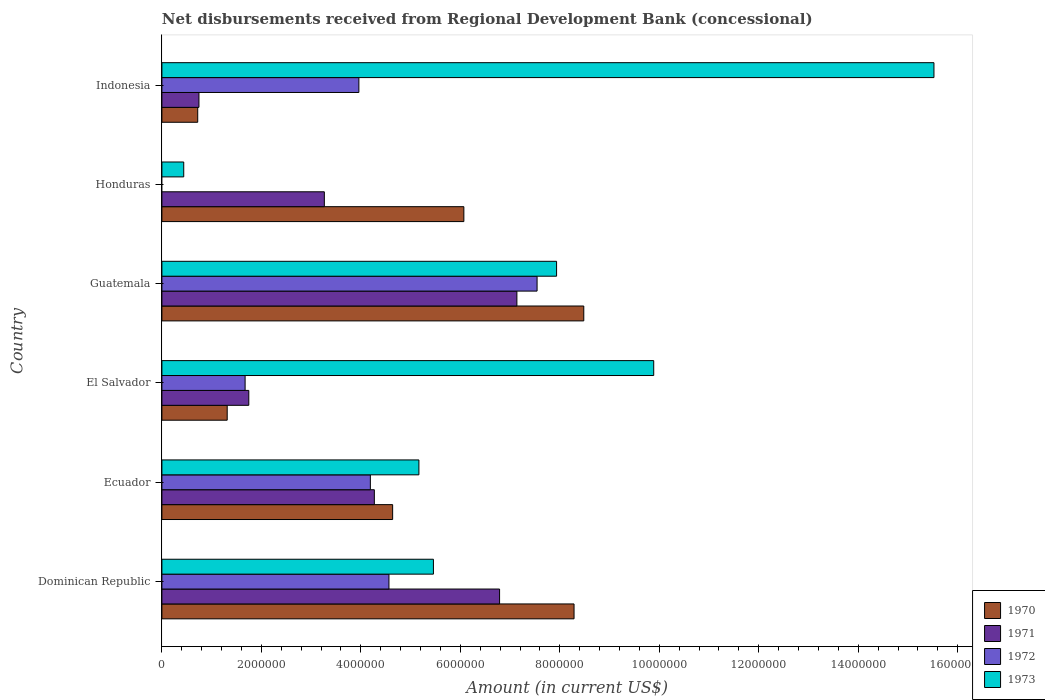How many different coloured bars are there?
Your answer should be very brief. 4. How many groups of bars are there?
Your answer should be compact. 6. Are the number of bars on each tick of the Y-axis equal?
Provide a short and direct response. No. What is the amount of disbursements received from Regional Development Bank in 1973 in Guatemala?
Your response must be concise. 7.94e+06. Across all countries, what is the maximum amount of disbursements received from Regional Development Bank in 1973?
Give a very brief answer. 1.55e+07. In which country was the amount of disbursements received from Regional Development Bank in 1970 maximum?
Ensure brevity in your answer.  Guatemala. What is the total amount of disbursements received from Regional Development Bank in 1971 in the graph?
Your answer should be compact. 2.40e+07. What is the difference between the amount of disbursements received from Regional Development Bank in 1973 in El Salvador and that in Guatemala?
Ensure brevity in your answer.  1.95e+06. What is the difference between the amount of disbursements received from Regional Development Bank in 1970 in Dominican Republic and the amount of disbursements received from Regional Development Bank in 1973 in Honduras?
Offer a terse response. 7.85e+06. What is the average amount of disbursements received from Regional Development Bank in 1970 per country?
Your answer should be compact. 4.92e+06. What is the difference between the amount of disbursements received from Regional Development Bank in 1970 and amount of disbursements received from Regional Development Bank in 1973 in Dominican Republic?
Offer a terse response. 2.83e+06. What is the ratio of the amount of disbursements received from Regional Development Bank in 1970 in Ecuador to that in El Salvador?
Provide a short and direct response. 3.53. Is the amount of disbursements received from Regional Development Bank in 1973 in Ecuador less than that in Guatemala?
Provide a short and direct response. Yes. What is the difference between the highest and the second highest amount of disbursements received from Regional Development Bank in 1973?
Make the answer very short. 5.63e+06. What is the difference between the highest and the lowest amount of disbursements received from Regional Development Bank in 1971?
Provide a succinct answer. 6.39e+06. Is the sum of the amount of disbursements received from Regional Development Bank in 1972 in Ecuador and Indonesia greater than the maximum amount of disbursements received from Regional Development Bank in 1970 across all countries?
Offer a terse response. No. Is it the case that in every country, the sum of the amount of disbursements received from Regional Development Bank in 1971 and amount of disbursements received from Regional Development Bank in 1970 is greater than the amount of disbursements received from Regional Development Bank in 1973?
Your answer should be compact. No. How many bars are there?
Offer a terse response. 23. Are all the bars in the graph horizontal?
Provide a succinct answer. Yes. How many countries are there in the graph?
Keep it short and to the point. 6. Are the values on the major ticks of X-axis written in scientific E-notation?
Make the answer very short. No. Does the graph contain any zero values?
Your answer should be compact. Yes. Where does the legend appear in the graph?
Your answer should be compact. Bottom right. How many legend labels are there?
Give a very brief answer. 4. How are the legend labels stacked?
Make the answer very short. Vertical. What is the title of the graph?
Keep it short and to the point. Net disbursements received from Regional Development Bank (concessional). What is the Amount (in current US$) in 1970 in Dominican Republic?
Keep it short and to the point. 8.29e+06. What is the Amount (in current US$) in 1971 in Dominican Republic?
Ensure brevity in your answer.  6.79e+06. What is the Amount (in current US$) of 1972 in Dominican Republic?
Provide a short and direct response. 4.56e+06. What is the Amount (in current US$) of 1973 in Dominican Republic?
Your answer should be compact. 5.46e+06. What is the Amount (in current US$) of 1970 in Ecuador?
Keep it short and to the point. 4.64e+06. What is the Amount (in current US$) of 1971 in Ecuador?
Keep it short and to the point. 4.27e+06. What is the Amount (in current US$) of 1972 in Ecuador?
Provide a succinct answer. 4.19e+06. What is the Amount (in current US$) of 1973 in Ecuador?
Keep it short and to the point. 5.17e+06. What is the Amount (in current US$) of 1970 in El Salvador?
Ensure brevity in your answer.  1.31e+06. What is the Amount (in current US$) of 1971 in El Salvador?
Offer a terse response. 1.75e+06. What is the Amount (in current US$) in 1972 in El Salvador?
Give a very brief answer. 1.67e+06. What is the Amount (in current US$) in 1973 in El Salvador?
Your answer should be very brief. 9.89e+06. What is the Amount (in current US$) of 1970 in Guatemala?
Keep it short and to the point. 8.48e+06. What is the Amount (in current US$) of 1971 in Guatemala?
Your answer should be compact. 7.14e+06. What is the Amount (in current US$) of 1972 in Guatemala?
Provide a succinct answer. 7.54e+06. What is the Amount (in current US$) of 1973 in Guatemala?
Your response must be concise. 7.94e+06. What is the Amount (in current US$) in 1970 in Honduras?
Make the answer very short. 6.07e+06. What is the Amount (in current US$) in 1971 in Honduras?
Offer a very short reply. 3.27e+06. What is the Amount (in current US$) of 1973 in Honduras?
Make the answer very short. 4.39e+05. What is the Amount (in current US$) in 1970 in Indonesia?
Offer a terse response. 7.20e+05. What is the Amount (in current US$) in 1971 in Indonesia?
Provide a short and direct response. 7.45e+05. What is the Amount (in current US$) in 1972 in Indonesia?
Make the answer very short. 3.96e+06. What is the Amount (in current US$) of 1973 in Indonesia?
Offer a terse response. 1.55e+07. Across all countries, what is the maximum Amount (in current US$) of 1970?
Offer a very short reply. 8.48e+06. Across all countries, what is the maximum Amount (in current US$) in 1971?
Provide a succinct answer. 7.14e+06. Across all countries, what is the maximum Amount (in current US$) of 1972?
Make the answer very short. 7.54e+06. Across all countries, what is the maximum Amount (in current US$) of 1973?
Give a very brief answer. 1.55e+07. Across all countries, what is the minimum Amount (in current US$) of 1970?
Keep it short and to the point. 7.20e+05. Across all countries, what is the minimum Amount (in current US$) of 1971?
Make the answer very short. 7.45e+05. Across all countries, what is the minimum Amount (in current US$) in 1972?
Provide a succinct answer. 0. Across all countries, what is the minimum Amount (in current US$) in 1973?
Provide a short and direct response. 4.39e+05. What is the total Amount (in current US$) of 1970 in the graph?
Provide a succinct answer. 2.95e+07. What is the total Amount (in current US$) in 1971 in the graph?
Ensure brevity in your answer.  2.40e+07. What is the total Amount (in current US$) in 1972 in the graph?
Your response must be concise. 2.19e+07. What is the total Amount (in current US$) in 1973 in the graph?
Your answer should be very brief. 4.44e+07. What is the difference between the Amount (in current US$) in 1970 in Dominican Republic and that in Ecuador?
Provide a short and direct response. 3.65e+06. What is the difference between the Amount (in current US$) in 1971 in Dominican Republic and that in Ecuador?
Make the answer very short. 2.52e+06. What is the difference between the Amount (in current US$) of 1972 in Dominican Republic and that in Ecuador?
Ensure brevity in your answer.  3.74e+05. What is the difference between the Amount (in current US$) in 1973 in Dominican Republic and that in Ecuador?
Your answer should be compact. 2.92e+05. What is the difference between the Amount (in current US$) in 1970 in Dominican Republic and that in El Salvador?
Keep it short and to the point. 6.97e+06. What is the difference between the Amount (in current US$) in 1971 in Dominican Republic and that in El Salvador?
Provide a succinct answer. 5.04e+06. What is the difference between the Amount (in current US$) in 1972 in Dominican Republic and that in El Salvador?
Your response must be concise. 2.89e+06. What is the difference between the Amount (in current US$) of 1973 in Dominican Republic and that in El Salvador?
Your answer should be very brief. -4.43e+06. What is the difference between the Amount (in current US$) in 1970 in Dominican Republic and that in Guatemala?
Offer a very short reply. -1.96e+05. What is the difference between the Amount (in current US$) in 1971 in Dominican Republic and that in Guatemala?
Make the answer very short. -3.48e+05. What is the difference between the Amount (in current US$) of 1972 in Dominican Republic and that in Guatemala?
Provide a succinct answer. -2.98e+06. What is the difference between the Amount (in current US$) in 1973 in Dominican Republic and that in Guatemala?
Offer a terse response. -2.48e+06. What is the difference between the Amount (in current US$) in 1970 in Dominican Republic and that in Honduras?
Ensure brevity in your answer.  2.22e+06. What is the difference between the Amount (in current US$) in 1971 in Dominican Republic and that in Honduras?
Make the answer very short. 3.52e+06. What is the difference between the Amount (in current US$) in 1973 in Dominican Republic and that in Honduras?
Provide a short and direct response. 5.02e+06. What is the difference between the Amount (in current US$) in 1970 in Dominican Republic and that in Indonesia?
Provide a succinct answer. 7.57e+06. What is the difference between the Amount (in current US$) in 1971 in Dominican Republic and that in Indonesia?
Your answer should be very brief. 6.04e+06. What is the difference between the Amount (in current US$) in 1972 in Dominican Republic and that in Indonesia?
Your response must be concise. 6.05e+05. What is the difference between the Amount (in current US$) of 1973 in Dominican Republic and that in Indonesia?
Give a very brief answer. -1.01e+07. What is the difference between the Amount (in current US$) in 1970 in Ecuador and that in El Salvador?
Your answer should be compact. 3.33e+06. What is the difference between the Amount (in current US$) of 1971 in Ecuador and that in El Salvador?
Make the answer very short. 2.52e+06. What is the difference between the Amount (in current US$) of 1972 in Ecuador and that in El Salvador?
Your answer should be compact. 2.52e+06. What is the difference between the Amount (in current US$) in 1973 in Ecuador and that in El Salvador?
Ensure brevity in your answer.  -4.72e+06. What is the difference between the Amount (in current US$) of 1970 in Ecuador and that in Guatemala?
Your answer should be very brief. -3.84e+06. What is the difference between the Amount (in current US$) in 1971 in Ecuador and that in Guatemala?
Provide a succinct answer. -2.87e+06. What is the difference between the Amount (in current US$) in 1972 in Ecuador and that in Guatemala?
Provide a succinct answer. -3.35e+06. What is the difference between the Amount (in current US$) of 1973 in Ecuador and that in Guatemala?
Your answer should be very brief. -2.77e+06. What is the difference between the Amount (in current US$) of 1970 in Ecuador and that in Honduras?
Provide a succinct answer. -1.43e+06. What is the difference between the Amount (in current US$) of 1971 in Ecuador and that in Honduras?
Provide a short and direct response. 1.00e+06. What is the difference between the Amount (in current US$) in 1973 in Ecuador and that in Honduras?
Offer a terse response. 4.73e+06. What is the difference between the Amount (in current US$) of 1970 in Ecuador and that in Indonesia?
Offer a very short reply. 3.92e+06. What is the difference between the Amount (in current US$) of 1971 in Ecuador and that in Indonesia?
Offer a terse response. 3.53e+06. What is the difference between the Amount (in current US$) of 1972 in Ecuador and that in Indonesia?
Offer a very short reply. 2.31e+05. What is the difference between the Amount (in current US$) in 1973 in Ecuador and that in Indonesia?
Give a very brief answer. -1.04e+07. What is the difference between the Amount (in current US$) of 1970 in El Salvador and that in Guatemala?
Provide a short and direct response. -7.17e+06. What is the difference between the Amount (in current US$) in 1971 in El Salvador and that in Guatemala?
Give a very brief answer. -5.39e+06. What is the difference between the Amount (in current US$) in 1972 in El Salvador and that in Guatemala?
Your response must be concise. -5.87e+06. What is the difference between the Amount (in current US$) in 1973 in El Salvador and that in Guatemala?
Give a very brief answer. 1.95e+06. What is the difference between the Amount (in current US$) of 1970 in El Salvador and that in Honduras?
Your answer should be compact. -4.76e+06. What is the difference between the Amount (in current US$) of 1971 in El Salvador and that in Honduras?
Provide a succinct answer. -1.52e+06. What is the difference between the Amount (in current US$) of 1973 in El Salvador and that in Honduras?
Keep it short and to the point. 9.45e+06. What is the difference between the Amount (in current US$) of 1970 in El Salvador and that in Indonesia?
Provide a succinct answer. 5.93e+05. What is the difference between the Amount (in current US$) of 1971 in El Salvador and that in Indonesia?
Offer a terse response. 1.00e+06. What is the difference between the Amount (in current US$) in 1972 in El Salvador and that in Indonesia?
Your response must be concise. -2.29e+06. What is the difference between the Amount (in current US$) in 1973 in El Salvador and that in Indonesia?
Offer a very short reply. -5.63e+06. What is the difference between the Amount (in current US$) in 1970 in Guatemala and that in Honduras?
Offer a very short reply. 2.41e+06. What is the difference between the Amount (in current US$) of 1971 in Guatemala and that in Honduras?
Make the answer very short. 3.87e+06. What is the difference between the Amount (in current US$) of 1973 in Guatemala and that in Honduras?
Provide a succinct answer. 7.50e+06. What is the difference between the Amount (in current US$) of 1970 in Guatemala and that in Indonesia?
Provide a short and direct response. 7.76e+06. What is the difference between the Amount (in current US$) of 1971 in Guatemala and that in Indonesia?
Make the answer very short. 6.39e+06. What is the difference between the Amount (in current US$) in 1972 in Guatemala and that in Indonesia?
Your answer should be very brief. 3.58e+06. What is the difference between the Amount (in current US$) in 1973 in Guatemala and that in Indonesia?
Your answer should be compact. -7.59e+06. What is the difference between the Amount (in current US$) of 1970 in Honduras and that in Indonesia?
Provide a succinct answer. 5.35e+06. What is the difference between the Amount (in current US$) of 1971 in Honduras and that in Indonesia?
Ensure brevity in your answer.  2.52e+06. What is the difference between the Amount (in current US$) of 1973 in Honduras and that in Indonesia?
Your answer should be compact. -1.51e+07. What is the difference between the Amount (in current US$) in 1970 in Dominican Republic and the Amount (in current US$) in 1971 in Ecuador?
Your response must be concise. 4.02e+06. What is the difference between the Amount (in current US$) in 1970 in Dominican Republic and the Amount (in current US$) in 1972 in Ecuador?
Make the answer very short. 4.10e+06. What is the difference between the Amount (in current US$) of 1970 in Dominican Republic and the Amount (in current US$) of 1973 in Ecuador?
Make the answer very short. 3.12e+06. What is the difference between the Amount (in current US$) of 1971 in Dominican Republic and the Amount (in current US$) of 1972 in Ecuador?
Give a very brief answer. 2.60e+06. What is the difference between the Amount (in current US$) in 1971 in Dominican Republic and the Amount (in current US$) in 1973 in Ecuador?
Your answer should be compact. 1.62e+06. What is the difference between the Amount (in current US$) in 1972 in Dominican Republic and the Amount (in current US$) in 1973 in Ecuador?
Provide a succinct answer. -6.02e+05. What is the difference between the Amount (in current US$) in 1970 in Dominican Republic and the Amount (in current US$) in 1971 in El Salvador?
Keep it short and to the point. 6.54e+06. What is the difference between the Amount (in current US$) of 1970 in Dominican Republic and the Amount (in current US$) of 1972 in El Salvador?
Provide a succinct answer. 6.61e+06. What is the difference between the Amount (in current US$) in 1970 in Dominican Republic and the Amount (in current US$) in 1973 in El Salvador?
Offer a very short reply. -1.60e+06. What is the difference between the Amount (in current US$) in 1971 in Dominican Republic and the Amount (in current US$) in 1972 in El Salvador?
Offer a very short reply. 5.12e+06. What is the difference between the Amount (in current US$) of 1971 in Dominican Republic and the Amount (in current US$) of 1973 in El Salvador?
Ensure brevity in your answer.  -3.10e+06. What is the difference between the Amount (in current US$) of 1972 in Dominican Republic and the Amount (in current US$) of 1973 in El Salvador?
Provide a succinct answer. -5.32e+06. What is the difference between the Amount (in current US$) of 1970 in Dominican Republic and the Amount (in current US$) of 1971 in Guatemala?
Your answer should be compact. 1.15e+06. What is the difference between the Amount (in current US$) of 1970 in Dominican Republic and the Amount (in current US$) of 1972 in Guatemala?
Your answer should be very brief. 7.43e+05. What is the difference between the Amount (in current US$) of 1970 in Dominican Republic and the Amount (in current US$) of 1973 in Guatemala?
Your response must be concise. 3.51e+05. What is the difference between the Amount (in current US$) in 1971 in Dominican Republic and the Amount (in current US$) in 1972 in Guatemala?
Provide a short and direct response. -7.54e+05. What is the difference between the Amount (in current US$) in 1971 in Dominican Republic and the Amount (in current US$) in 1973 in Guatemala?
Your answer should be compact. -1.15e+06. What is the difference between the Amount (in current US$) in 1972 in Dominican Republic and the Amount (in current US$) in 1973 in Guatemala?
Provide a short and direct response. -3.37e+06. What is the difference between the Amount (in current US$) in 1970 in Dominican Republic and the Amount (in current US$) in 1971 in Honduras?
Make the answer very short. 5.02e+06. What is the difference between the Amount (in current US$) of 1970 in Dominican Republic and the Amount (in current US$) of 1973 in Honduras?
Give a very brief answer. 7.85e+06. What is the difference between the Amount (in current US$) of 1971 in Dominican Republic and the Amount (in current US$) of 1973 in Honduras?
Provide a short and direct response. 6.35e+06. What is the difference between the Amount (in current US$) in 1972 in Dominican Republic and the Amount (in current US$) in 1973 in Honduras?
Your answer should be compact. 4.13e+06. What is the difference between the Amount (in current US$) of 1970 in Dominican Republic and the Amount (in current US$) of 1971 in Indonesia?
Keep it short and to the point. 7.54e+06. What is the difference between the Amount (in current US$) in 1970 in Dominican Republic and the Amount (in current US$) in 1972 in Indonesia?
Ensure brevity in your answer.  4.33e+06. What is the difference between the Amount (in current US$) in 1970 in Dominican Republic and the Amount (in current US$) in 1973 in Indonesia?
Give a very brief answer. -7.24e+06. What is the difference between the Amount (in current US$) of 1971 in Dominican Republic and the Amount (in current US$) of 1972 in Indonesia?
Your response must be concise. 2.83e+06. What is the difference between the Amount (in current US$) of 1971 in Dominican Republic and the Amount (in current US$) of 1973 in Indonesia?
Your response must be concise. -8.73e+06. What is the difference between the Amount (in current US$) in 1972 in Dominican Republic and the Amount (in current US$) in 1973 in Indonesia?
Provide a succinct answer. -1.10e+07. What is the difference between the Amount (in current US$) in 1970 in Ecuador and the Amount (in current US$) in 1971 in El Salvador?
Offer a very short reply. 2.89e+06. What is the difference between the Amount (in current US$) in 1970 in Ecuador and the Amount (in current US$) in 1972 in El Salvador?
Your response must be concise. 2.97e+06. What is the difference between the Amount (in current US$) in 1970 in Ecuador and the Amount (in current US$) in 1973 in El Salvador?
Keep it short and to the point. -5.25e+06. What is the difference between the Amount (in current US$) in 1971 in Ecuador and the Amount (in current US$) in 1972 in El Salvador?
Provide a succinct answer. 2.60e+06. What is the difference between the Amount (in current US$) in 1971 in Ecuador and the Amount (in current US$) in 1973 in El Salvador?
Make the answer very short. -5.62e+06. What is the difference between the Amount (in current US$) of 1972 in Ecuador and the Amount (in current US$) of 1973 in El Salvador?
Offer a very short reply. -5.70e+06. What is the difference between the Amount (in current US$) of 1970 in Ecuador and the Amount (in current US$) of 1971 in Guatemala?
Give a very brief answer. -2.50e+06. What is the difference between the Amount (in current US$) in 1970 in Ecuador and the Amount (in current US$) in 1972 in Guatemala?
Provide a succinct answer. -2.90e+06. What is the difference between the Amount (in current US$) of 1970 in Ecuador and the Amount (in current US$) of 1973 in Guatemala?
Offer a very short reply. -3.30e+06. What is the difference between the Amount (in current US$) in 1971 in Ecuador and the Amount (in current US$) in 1972 in Guatemala?
Provide a succinct answer. -3.27e+06. What is the difference between the Amount (in current US$) of 1971 in Ecuador and the Amount (in current US$) of 1973 in Guatemala?
Provide a succinct answer. -3.66e+06. What is the difference between the Amount (in current US$) in 1972 in Ecuador and the Amount (in current US$) in 1973 in Guatemala?
Offer a very short reply. -3.74e+06. What is the difference between the Amount (in current US$) in 1970 in Ecuador and the Amount (in current US$) in 1971 in Honduras?
Keep it short and to the point. 1.37e+06. What is the difference between the Amount (in current US$) of 1970 in Ecuador and the Amount (in current US$) of 1973 in Honduras?
Offer a terse response. 4.20e+06. What is the difference between the Amount (in current US$) of 1971 in Ecuador and the Amount (in current US$) of 1973 in Honduras?
Your answer should be compact. 3.83e+06. What is the difference between the Amount (in current US$) in 1972 in Ecuador and the Amount (in current US$) in 1973 in Honduras?
Offer a terse response. 3.75e+06. What is the difference between the Amount (in current US$) in 1970 in Ecuador and the Amount (in current US$) in 1971 in Indonesia?
Offer a very short reply. 3.89e+06. What is the difference between the Amount (in current US$) of 1970 in Ecuador and the Amount (in current US$) of 1972 in Indonesia?
Provide a succinct answer. 6.79e+05. What is the difference between the Amount (in current US$) of 1970 in Ecuador and the Amount (in current US$) of 1973 in Indonesia?
Your response must be concise. -1.09e+07. What is the difference between the Amount (in current US$) in 1971 in Ecuador and the Amount (in current US$) in 1972 in Indonesia?
Provide a short and direct response. 3.11e+05. What is the difference between the Amount (in current US$) in 1971 in Ecuador and the Amount (in current US$) in 1973 in Indonesia?
Make the answer very short. -1.13e+07. What is the difference between the Amount (in current US$) of 1972 in Ecuador and the Amount (in current US$) of 1973 in Indonesia?
Provide a short and direct response. -1.13e+07. What is the difference between the Amount (in current US$) in 1970 in El Salvador and the Amount (in current US$) in 1971 in Guatemala?
Offer a terse response. -5.82e+06. What is the difference between the Amount (in current US$) in 1970 in El Salvador and the Amount (in current US$) in 1972 in Guatemala?
Give a very brief answer. -6.23e+06. What is the difference between the Amount (in current US$) in 1970 in El Salvador and the Amount (in current US$) in 1973 in Guatemala?
Give a very brief answer. -6.62e+06. What is the difference between the Amount (in current US$) in 1971 in El Salvador and the Amount (in current US$) in 1972 in Guatemala?
Your answer should be compact. -5.80e+06. What is the difference between the Amount (in current US$) of 1971 in El Salvador and the Amount (in current US$) of 1973 in Guatemala?
Keep it short and to the point. -6.19e+06. What is the difference between the Amount (in current US$) in 1972 in El Salvador and the Amount (in current US$) in 1973 in Guatemala?
Give a very brief answer. -6.26e+06. What is the difference between the Amount (in current US$) of 1970 in El Salvador and the Amount (in current US$) of 1971 in Honduras?
Offer a very short reply. -1.95e+06. What is the difference between the Amount (in current US$) of 1970 in El Salvador and the Amount (in current US$) of 1973 in Honduras?
Give a very brief answer. 8.74e+05. What is the difference between the Amount (in current US$) of 1971 in El Salvador and the Amount (in current US$) of 1973 in Honduras?
Offer a terse response. 1.31e+06. What is the difference between the Amount (in current US$) of 1972 in El Salvador and the Amount (in current US$) of 1973 in Honduras?
Your answer should be compact. 1.23e+06. What is the difference between the Amount (in current US$) in 1970 in El Salvador and the Amount (in current US$) in 1971 in Indonesia?
Offer a very short reply. 5.68e+05. What is the difference between the Amount (in current US$) in 1970 in El Salvador and the Amount (in current US$) in 1972 in Indonesia?
Offer a very short reply. -2.65e+06. What is the difference between the Amount (in current US$) of 1970 in El Salvador and the Amount (in current US$) of 1973 in Indonesia?
Give a very brief answer. -1.42e+07. What is the difference between the Amount (in current US$) in 1971 in El Salvador and the Amount (in current US$) in 1972 in Indonesia?
Your answer should be very brief. -2.21e+06. What is the difference between the Amount (in current US$) in 1971 in El Salvador and the Amount (in current US$) in 1973 in Indonesia?
Provide a succinct answer. -1.38e+07. What is the difference between the Amount (in current US$) in 1972 in El Salvador and the Amount (in current US$) in 1973 in Indonesia?
Give a very brief answer. -1.38e+07. What is the difference between the Amount (in current US$) in 1970 in Guatemala and the Amount (in current US$) in 1971 in Honduras?
Keep it short and to the point. 5.22e+06. What is the difference between the Amount (in current US$) in 1970 in Guatemala and the Amount (in current US$) in 1973 in Honduras?
Make the answer very short. 8.04e+06. What is the difference between the Amount (in current US$) of 1971 in Guatemala and the Amount (in current US$) of 1973 in Honduras?
Your answer should be compact. 6.70e+06. What is the difference between the Amount (in current US$) of 1972 in Guatemala and the Amount (in current US$) of 1973 in Honduras?
Make the answer very short. 7.10e+06. What is the difference between the Amount (in current US$) in 1970 in Guatemala and the Amount (in current US$) in 1971 in Indonesia?
Provide a succinct answer. 7.74e+06. What is the difference between the Amount (in current US$) in 1970 in Guatemala and the Amount (in current US$) in 1972 in Indonesia?
Provide a short and direct response. 4.52e+06. What is the difference between the Amount (in current US$) of 1970 in Guatemala and the Amount (in current US$) of 1973 in Indonesia?
Offer a terse response. -7.04e+06. What is the difference between the Amount (in current US$) in 1971 in Guatemala and the Amount (in current US$) in 1972 in Indonesia?
Offer a terse response. 3.18e+06. What is the difference between the Amount (in current US$) of 1971 in Guatemala and the Amount (in current US$) of 1973 in Indonesia?
Offer a terse response. -8.38e+06. What is the difference between the Amount (in current US$) in 1972 in Guatemala and the Amount (in current US$) in 1973 in Indonesia?
Make the answer very short. -7.98e+06. What is the difference between the Amount (in current US$) in 1970 in Honduras and the Amount (in current US$) in 1971 in Indonesia?
Offer a terse response. 5.33e+06. What is the difference between the Amount (in current US$) in 1970 in Honduras and the Amount (in current US$) in 1972 in Indonesia?
Provide a succinct answer. 2.11e+06. What is the difference between the Amount (in current US$) of 1970 in Honduras and the Amount (in current US$) of 1973 in Indonesia?
Provide a succinct answer. -9.45e+06. What is the difference between the Amount (in current US$) in 1971 in Honduras and the Amount (in current US$) in 1972 in Indonesia?
Your answer should be very brief. -6.94e+05. What is the difference between the Amount (in current US$) of 1971 in Honduras and the Amount (in current US$) of 1973 in Indonesia?
Keep it short and to the point. -1.23e+07. What is the average Amount (in current US$) in 1970 per country?
Your answer should be very brief. 4.92e+06. What is the average Amount (in current US$) of 1971 per country?
Give a very brief answer. 3.99e+06. What is the average Amount (in current US$) of 1972 per country?
Provide a short and direct response. 3.66e+06. What is the average Amount (in current US$) of 1973 per country?
Make the answer very short. 7.40e+06. What is the difference between the Amount (in current US$) in 1970 and Amount (in current US$) in 1971 in Dominican Republic?
Ensure brevity in your answer.  1.50e+06. What is the difference between the Amount (in current US$) in 1970 and Amount (in current US$) in 1972 in Dominican Republic?
Offer a terse response. 3.72e+06. What is the difference between the Amount (in current US$) of 1970 and Amount (in current US$) of 1973 in Dominican Republic?
Give a very brief answer. 2.83e+06. What is the difference between the Amount (in current US$) of 1971 and Amount (in current US$) of 1972 in Dominican Republic?
Your response must be concise. 2.22e+06. What is the difference between the Amount (in current US$) in 1971 and Amount (in current US$) in 1973 in Dominican Republic?
Your answer should be compact. 1.33e+06. What is the difference between the Amount (in current US$) of 1972 and Amount (in current US$) of 1973 in Dominican Republic?
Make the answer very short. -8.94e+05. What is the difference between the Amount (in current US$) of 1970 and Amount (in current US$) of 1971 in Ecuador?
Provide a succinct answer. 3.68e+05. What is the difference between the Amount (in current US$) in 1970 and Amount (in current US$) in 1972 in Ecuador?
Give a very brief answer. 4.48e+05. What is the difference between the Amount (in current US$) of 1970 and Amount (in current US$) of 1973 in Ecuador?
Offer a very short reply. -5.28e+05. What is the difference between the Amount (in current US$) in 1971 and Amount (in current US$) in 1972 in Ecuador?
Make the answer very short. 8.00e+04. What is the difference between the Amount (in current US$) in 1971 and Amount (in current US$) in 1973 in Ecuador?
Keep it short and to the point. -8.96e+05. What is the difference between the Amount (in current US$) of 1972 and Amount (in current US$) of 1973 in Ecuador?
Provide a short and direct response. -9.76e+05. What is the difference between the Amount (in current US$) in 1970 and Amount (in current US$) in 1971 in El Salvador?
Offer a terse response. -4.34e+05. What is the difference between the Amount (in current US$) of 1970 and Amount (in current US$) of 1972 in El Salvador?
Make the answer very short. -3.60e+05. What is the difference between the Amount (in current US$) of 1970 and Amount (in current US$) of 1973 in El Salvador?
Provide a short and direct response. -8.58e+06. What is the difference between the Amount (in current US$) in 1971 and Amount (in current US$) in 1972 in El Salvador?
Your answer should be very brief. 7.40e+04. What is the difference between the Amount (in current US$) of 1971 and Amount (in current US$) of 1973 in El Salvador?
Provide a short and direct response. -8.14e+06. What is the difference between the Amount (in current US$) of 1972 and Amount (in current US$) of 1973 in El Salvador?
Offer a terse response. -8.22e+06. What is the difference between the Amount (in current US$) of 1970 and Amount (in current US$) of 1971 in Guatemala?
Offer a very short reply. 1.34e+06. What is the difference between the Amount (in current US$) in 1970 and Amount (in current US$) in 1972 in Guatemala?
Offer a terse response. 9.39e+05. What is the difference between the Amount (in current US$) in 1970 and Amount (in current US$) in 1973 in Guatemala?
Ensure brevity in your answer.  5.47e+05. What is the difference between the Amount (in current US$) of 1971 and Amount (in current US$) of 1972 in Guatemala?
Offer a very short reply. -4.06e+05. What is the difference between the Amount (in current US$) of 1971 and Amount (in current US$) of 1973 in Guatemala?
Give a very brief answer. -7.98e+05. What is the difference between the Amount (in current US$) in 1972 and Amount (in current US$) in 1973 in Guatemala?
Keep it short and to the point. -3.92e+05. What is the difference between the Amount (in current US$) of 1970 and Amount (in current US$) of 1971 in Honduras?
Your response must be concise. 2.80e+06. What is the difference between the Amount (in current US$) in 1970 and Amount (in current US$) in 1973 in Honduras?
Your answer should be very brief. 5.63e+06. What is the difference between the Amount (in current US$) of 1971 and Amount (in current US$) of 1973 in Honduras?
Ensure brevity in your answer.  2.83e+06. What is the difference between the Amount (in current US$) of 1970 and Amount (in current US$) of 1971 in Indonesia?
Your response must be concise. -2.50e+04. What is the difference between the Amount (in current US$) in 1970 and Amount (in current US$) in 1972 in Indonesia?
Offer a terse response. -3.24e+06. What is the difference between the Amount (in current US$) in 1970 and Amount (in current US$) in 1973 in Indonesia?
Your answer should be compact. -1.48e+07. What is the difference between the Amount (in current US$) of 1971 and Amount (in current US$) of 1972 in Indonesia?
Your response must be concise. -3.22e+06. What is the difference between the Amount (in current US$) in 1971 and Amount (in current US$) in 1973 in Indonesia?
Make the answer very short. -1.48e+07. What is the difference between the Amount (in current US$) in 1972 and Amount (in current US$) in 1973 in Indonesia?
Keep it short and to the point. -1.16e+07. What is the ratio of the Amount (in current US$) of 1970 in Dominican Republic to that in Ecuador?
Offer a terse response. 1.79. What is the ratio of the Amount (in current US$) of 1971 in Dominican Republic to that in Ecuador?
Your answer should be very brief. 1.59. What is the ratio of the Amount (in current US$) of 1972 in Dominican Republic to that in Ecuador?
Give a very brief answer. 1.09. What is the ratio of the Amount (in current US$) in 1973 in Dominican Republic to that in Ecuador?
Give a very brief answer. 1.06. What is the ratio of the Amount (in current US$) of 1970 in Dominican Republic to that in El Salvador?
Keep it short and to the point. 6.31. What is the ratio of the Amount (in current US$) in 1971 in Dominican Republic to that in El Salvador?
Your answer should be very brief. 3.89. What is the ratio of the Amount (in current US$) in 1972 in Dominican Republic to that in El Salvador?
Keep it short and to the point. 2.73. What is the ratio of the Amount (in current US$) in 1973 in Dominican Republic to that in El Salvador?
Give a very brief answer. 0.55. What is the ratio of the Amount (in current US$) in 1970 in Dominican Republic to that in Guatemala?
Keep it short and to the point. 0.98. What is the ratio of the Amount (in current US$) of 1971 in Dominican Republic to that in Guatemala?
Your response must be concise. 0.95. What is the ratio of the Amount (in current US$) in 1972 in Dominican Republic to that in Guatemala?
Give a very brief answer. 0.61. What is the ratio of the Amount (in current US$) in 1973 in Dominican Republic to that in Guatemala?
Ensure brevity in your answer.  0.69. What is the ratio of the Amount (in current US$) of 1970 in Dominican Republic to that in Honduras?
Offer a very short reply. 1.36. What is the ratio of the Amount (in current US$) in 1971 in Dominican Republic to that in Honduras?
Offer a very short reply. 2.08. What is the ratio of the Amount (in current US$) of 1973 in Dominican Republic to that in Honduras?
Your answer should be compact. 12.44. What is the ratio of the Amount (in current US$) of 1970 in Dominican Republic to that in Indonesia?
Give a very brief answer. 11.51. What is the ratio of the Amount (in current US$) in 1971 in Dominican Republic to that in Indonesia?
Ensure brevity in your answer.  9.11. What is the ratio of the Amount (in current US$) in 1972 in Dominican Republic to that in Indonesia?
Make the answer very short. 1.15. What is the ratio of the Amount (in current US$) in 1973 in Dominican Republic to that in Indonesia?
Your answer should be compact. 0.35. What is the ratio of the Amount (in current US$) in 1970 in Ecuador to that in El Salvador?
Your answer should be compact. 3.53. What is the ratio of the Amount (in current US$) of 1971 in Ecuador to that in El Salvador?
Keep it short and to the point. 2.44. What is the ratio of the Amount (in current US$) of 1972 in Ecuador to that in El Salvador?
Your response must be concise. 2.51. What is the ratio of the Amount (in current US$) in 1973 in Ecuador to that in El Salvador?
Make the answer very short. 0.52. What is the ratio of the Amount (in current US$) in 1970 in Ecuador to that in Guatemala?
Your answer should be compact. 0.55. What is the ratio of the Amount (in current US$) in 1971 in Ecuador to that in Guatemala?
Your answer should be compact. 0.6. What is the ratio of the Amount (in current US$) of 1972 in Ecuador to that in Guatemala?
Offer a terse response. 0.56. What is the ratio of the Amount (in current US$) of 1973 in Ecuador to that in Guatemala?
Your answer should be compact. 0.65. What is the ratio of the Amount (in current US$) in 1970 in Ecuador to that in Honduras?
Make the answer very short. 0.76. What is the ratio of the Amount (in current US$) in 1971 in Ecuador to that in Honduras?
Offer a terse response. 1.31. What is the ratio of the Amount (in current US$) in 1973 in Ecuador to that in Honduras?
Your answer should be very brief. 11.77. What is the ratio of the Amount (in current US$) of 1970 in Ecuador to that in Indonesia?
Keep it short and to the point. 6.44. What is the ratio of the Amount (in current US$) in 1971 in Ecuador to that in Indonesia?
Offer a very short reply. 5.73. What is the ratio of the Amount (in current US$) in 1972 in Ecuador to that in Indonesia?
Offer a very short reply. 1.06. What is the ratio of the Amount (in current US$) of 1973 in Ecuador to that in Indonesia?
Make the answer very short. 0.33. What is the ratio of the Amount (in current US$) in 1970 in El Salvador to that in Guatemala?
Provide a succinct answer. 0.15. What is the ratio of the Amount (in current US$) in 1971 in El Salvador to that in Guatemala?
Provide a short and direct response. 0.24. What is the ratio of the Amount (in current US$) in 1972 in El Salvador to that in Guatemala?
Keep it short and to the point. 0.22. What is the ratio of the Amount (in current US$) of 1973 in El Salvador to that in Guatemala?
Your answer should be compact. 1.25. What is the ratio of the Amount (in current US$) of 1970 in El Salvador to that in Honduras?
Your answer should be very brief. 0.22. What is the ratio of the Amount (in current US$) in 1971 in El Salvador to that in Honduras?
Provide a succinct answer. 0.53. What is the ratio of the Amount (in current US$) of 1973 in El Salvador to that in Honduras?
Your answer should be very brief. 22.52. What is the ratio of the Amount (in current US$) of 1970 in El Salvador to that in Indonesia?
Offer a terse response. 1.82. What is the ratio of the Amount (in current US$) of 1971 in El Salvador to that in Indonesia?
Provide a succinct answer. 2.35. What is the ratio of the Amount (in current US$) of 1972 in El Salvador to that in Indonesia?
Provide a short and direct response. 0.42. What is the ratio of the Amount (in current US$) in 1973 in El Salvador to that in Indonesia?
Offer a terse response. 0.64. What is the ratio of the Amount (in current US$) in 1970 in Guatemala to that in Honduras?
Your response must be concise. 1.4. What is the ratio of the Amount (in current US$) of 1971 in Guatemala to that in Honduras?
Make the answer very short. 2.19. What is the ratio of the Amount (in current US$) of 1973 in Guatemala to that in Honduras?
Provide a succinct answer. 18.08. What is the ratio of the Amount (in current US$) in 1970 in Guatemala to that in Indonesia?
Offer a terse response. 11.78. What is the ratio of the Amount (in current US$) in 1971 in Guatemala to that in Indonesia?
Provide a succinct answer. 9.58. What is the ratio of the Amount (in current US$) of 1972 in Guatemala to that in Indonesia?
Provide a short and direct response. 1.9. What is the ratio of the Amount (in current US$) in 1973 in Guatemala to that in Indonesia?
Make the answer very short. 0.51. What is the ratio of the Amount (in current US$) of 1970 in Honduras to that in Indonesia?
Give a very brief answer. 8.43. What is the ratio of the Amount (in current US$) of 1971 in Honduras to that in Indonesia?
Provide a short and direct response. 4.38. What is the ratio of the Amount (in current US$) of 1973 in Honduras to that in Indonesia?
Provide a succinct answer. 0.03. What is the difference between the highest and the second highest Amount (in current US$) in 1970?
Your answer should be compact. 1.96e+05. What is the difference between the highest and the second highest Amount (in current US$) in 1971?
Your answer should be very brief. 3.48e+05. What is the difference between the highest and the second highest Amount (in current US$) in 1972?
Your response must be concise. 2.98e+06. What is the difference between the highest and the second highest Amount (in current US$) of 1973?
Provide a succinct answer. 5.63e+06. What is the difference between the highest and the lowest Amount (in current US$) in 1970?
Ensure brevity in your answer.  7.76e+06. What is the difference between the highest and the lowest Amount (in current US$) in 1971?
Your answer should be very brief. 6.39e+06. What is the difference between the highest and the lowest Amount (in current US$) in 1972?
Make the answer very short. 7.54e+06. What is the difference between the highest and the lowest Amount (in current US$) in 1973?
Make the answer very short. 1.51e+07. 